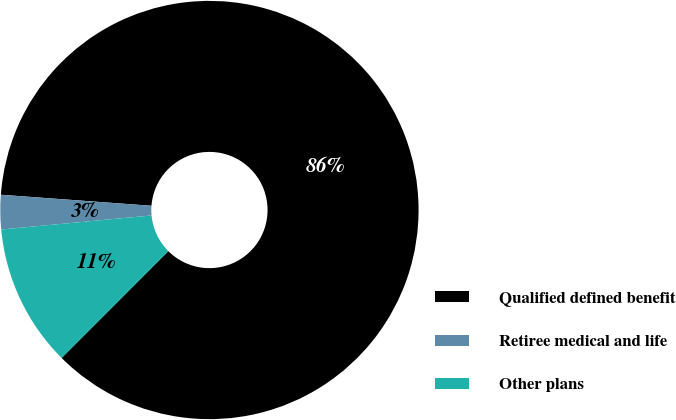Convert chart. <chart><loc_0><loc_0><loc_500><loc_500><pie_chart><fcel>Qualified defined benefit<fcel>Retiree medical and life<fcel>Other plans<nl><fcel>86.33%<fcel>2.65%<fcel>11.02%<nl></chart> 